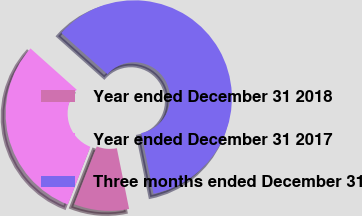Convert chart to OTSL. <chart><loc_0><loc_0><loc_500><loc_500><pie_chart><fcel>Year ended December 31 2018<fcel>Year ended December 31 2017<fcel>Three months ended December 31<nl><fcel>9.09%<fcel>30.68%<fcel>60.23%<nl></chart> 